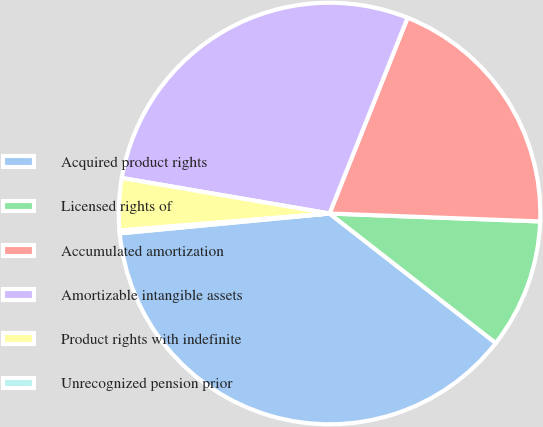Convert chart. <chart><loc_0><loc_0><loc_500><loc_500><pie_chart><fcel>Acquired product rights<fcel>Licensed rights of<fcel>Accumulated amortization<fcel>Amortizable intangible assets<fcel>Product rights with indefinite<fcel>Unrecognized pension prior<nl><fcel>37.96%<fcel>9.94%<fcel>19.56%<fcel>28.34%<fcel>3.99%<fcel>0.21%<nl></chart> 